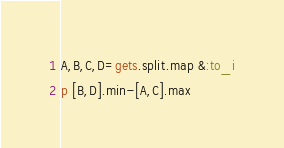Convert code to text. <code><loc_0><loc_0><loc_500><loc_500><_Ruby_>A,B,C,D=gets.split.map &:to_i
p [B,D].min-[A,C].max</code> 